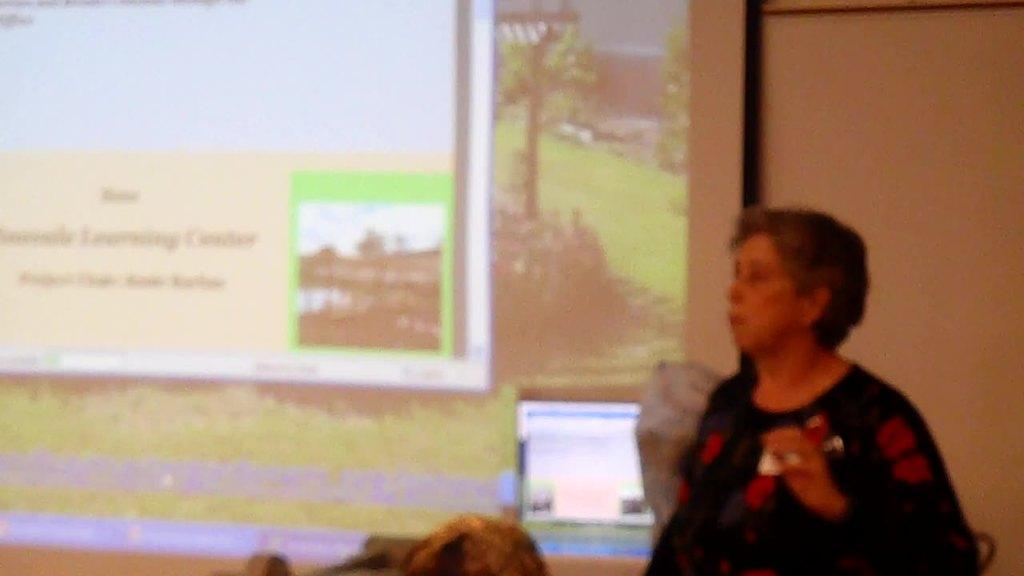Who is present on the right side of the image? There is a lady on the right side of the image. What can be seen on the left side of the image? There is a screen with images on the left side of the image. What type of beetle can be seen crawling on the lady's shoulder in the image? There is no beetle present on the lady's shoulder in the image. What flavor of cracker is the lady holding in the image? The lady is not holding a cracker in the image. 